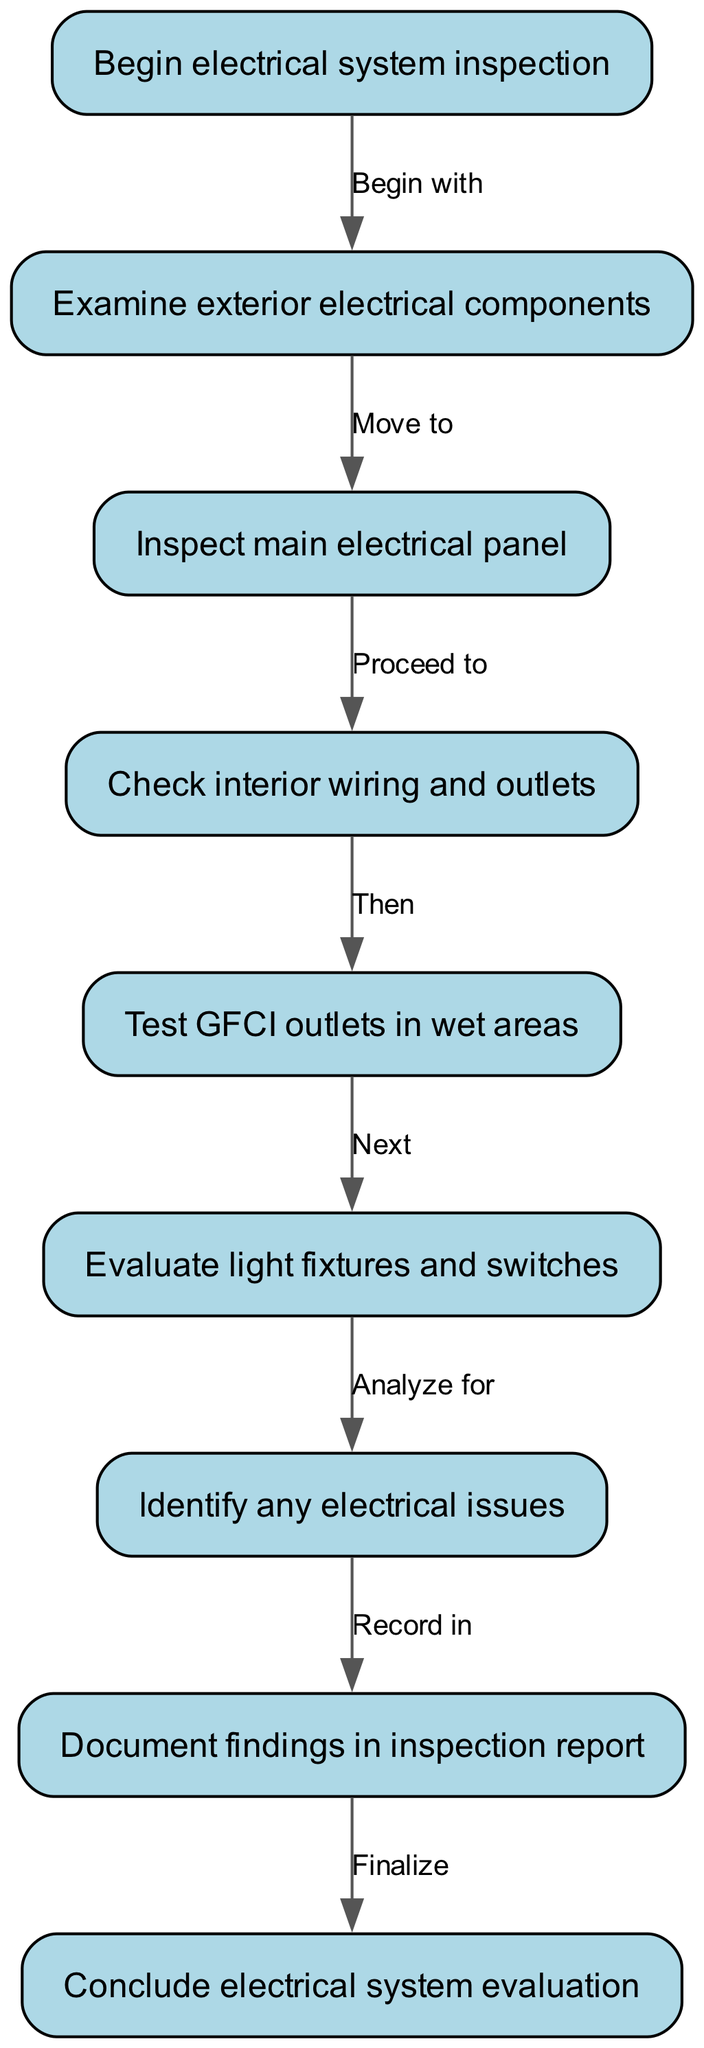What is the first step in the electrical system inspection? The diagram indicates that the first step is to "Begin electrical system inspection." This is represented as the starting node of the flow chart.
Answer: Begin electrical system inspection How many nodes are there in the workflow? By counting the nodes listed in the diagram (Begin inspection, Examine exterior components, Inspect main panel, Check wiring, Test GFCI outlets, Evaluate fixtures, Identify issues, Document findings, Conclude evaluation), we find there are nine nodes total.
Answer: Nine What follows after inspecting the main electrical panel? According to the flow chart, after inspecting the main electrical panel, the next step is to "Check interior wiring and outlets." This is specified as the next node connected to the main panel node.
Answer: Check interior wiring and outlets What step comes before concluding the evaluation? The flow chart shows that prior to "Conclude electrical system evaluation," the step is to "Document findings in inspection report." This indicates that recording findings occurs just before the conclusion.
Answer: Document findings in inspection report Which component is evaluated after testing GFCI outlets? From the diagram, after testing GFCI outlets in wet areas, the next component to evaluate is "light fixtures and switches." This shows the direct progression from one step to the next.
Answer: Evaluate light fixtures and switches What is the last action taken in the electrical inspection process? The final action in the flow chart is labeled as "Conclude electrical system evaluation," appearing as the last node in the sequence, which indicates the completion of the inspection process.
Answer: Conclude electrical system evaluation What type of electrical components does the inspection begin with? The inspection starts with an examination of "exterior electrical components," meaning the focus is on the outdoor parts of the electrical system at the start of the evaluation workflow.
Answer: Examine exterior electrical components How would you categorize the step "Identify any electrical issues"? This step acts as an analysis phase within the workflow. It is where observed problems are consolidated, leading to documentation, thus categorizing it as a critical evaluation step in the process.
Answer: Analyze for issues What action is taken after analyzing for electrical issues? Following the analysis phase where issues are identified, the next action according to the flow chart is to "Document findings in inspection report," which indicates the progression towards formal record-keeping after evaluation.
Answer: Document findings in inspection report 